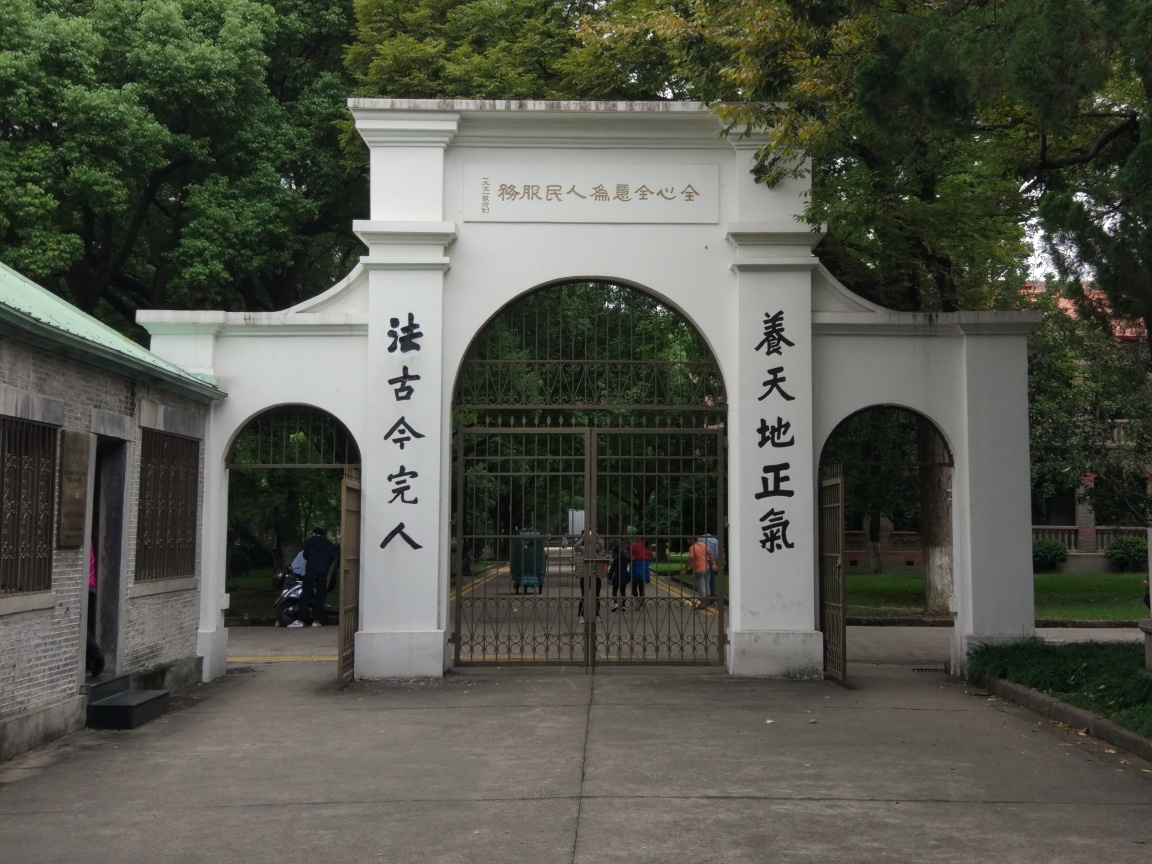Can you tell me more about the text on the gate and what this place might be? The text on the gate is written in Chinese characters. Each pillar bears part of what appears to be a name or a title. Such gates often serve as entrances to places of importance such as universities, historical sites, or government buildings in Chinese-speaking regions. Without specific regional information, it's difficult to pinpoint exactly what this place is, but it's likely an institution of cultural, educational, or historical significance. 